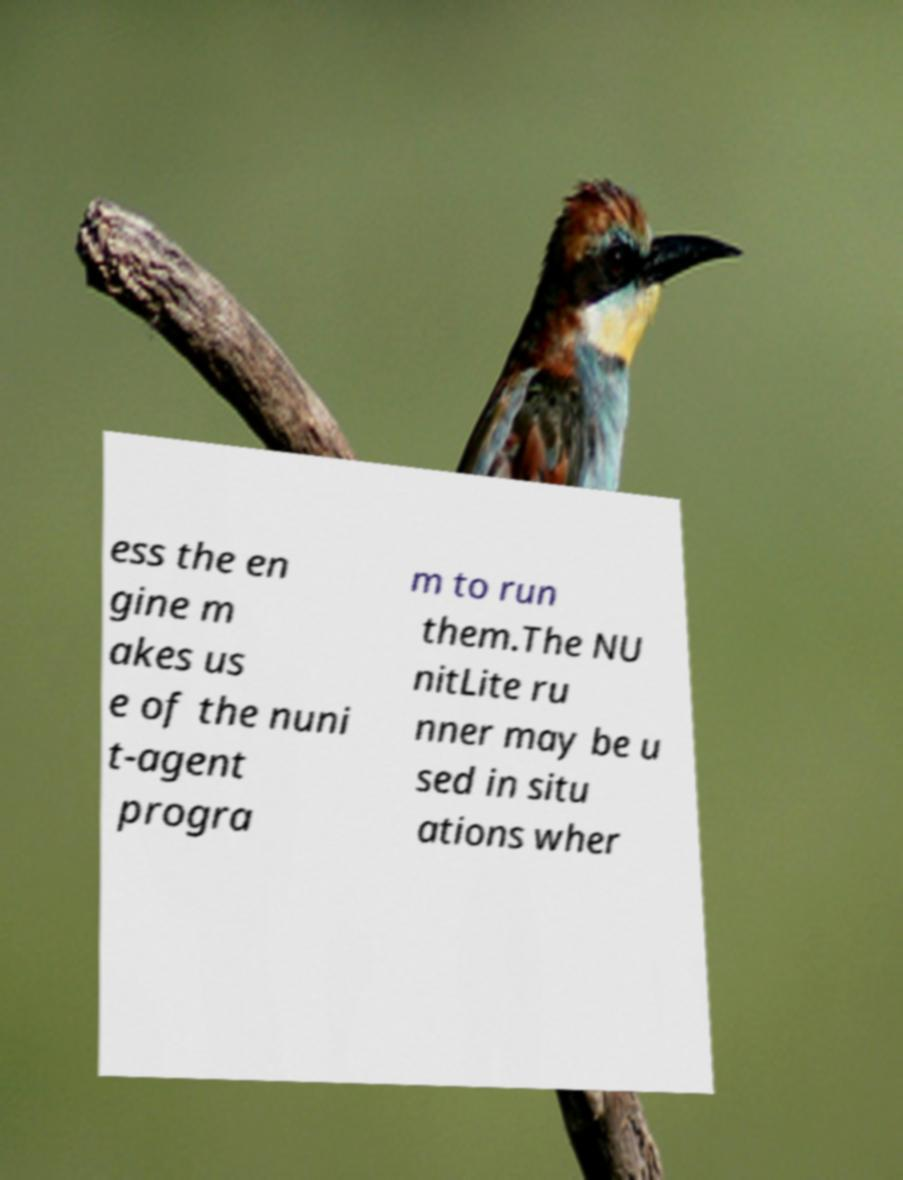Could you extract and type out the text from this image? ess the en gine m akes us e of the nuni t-agent progra m to run them.The NU nitLite ru nner may be u sed in situ ations wher 